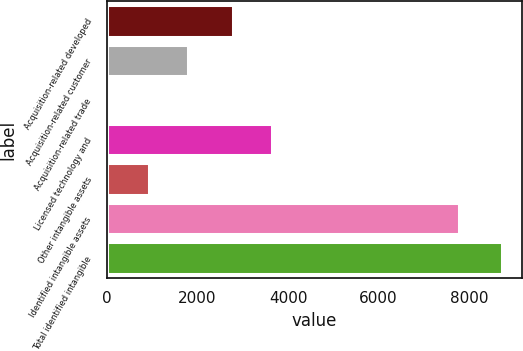Convert chart to OTSL. <chart><loc_0><loc_0><loc_500><loc_500><bar_chart><fcel>Acquisition-related developed<fcel>Acquisition-related customer<fcel>Acquisition-related trade<fcel>Licensed technology and<fcel>Other intangible assets<fcel>Identified intangible assets<fcel>Total identified intangible<nl><fcel>2778<fcel>1798.4<fcel>68<fcel>3643.2<fcel>933.2<fcel>7782<fcel>8720<nl></chart> 